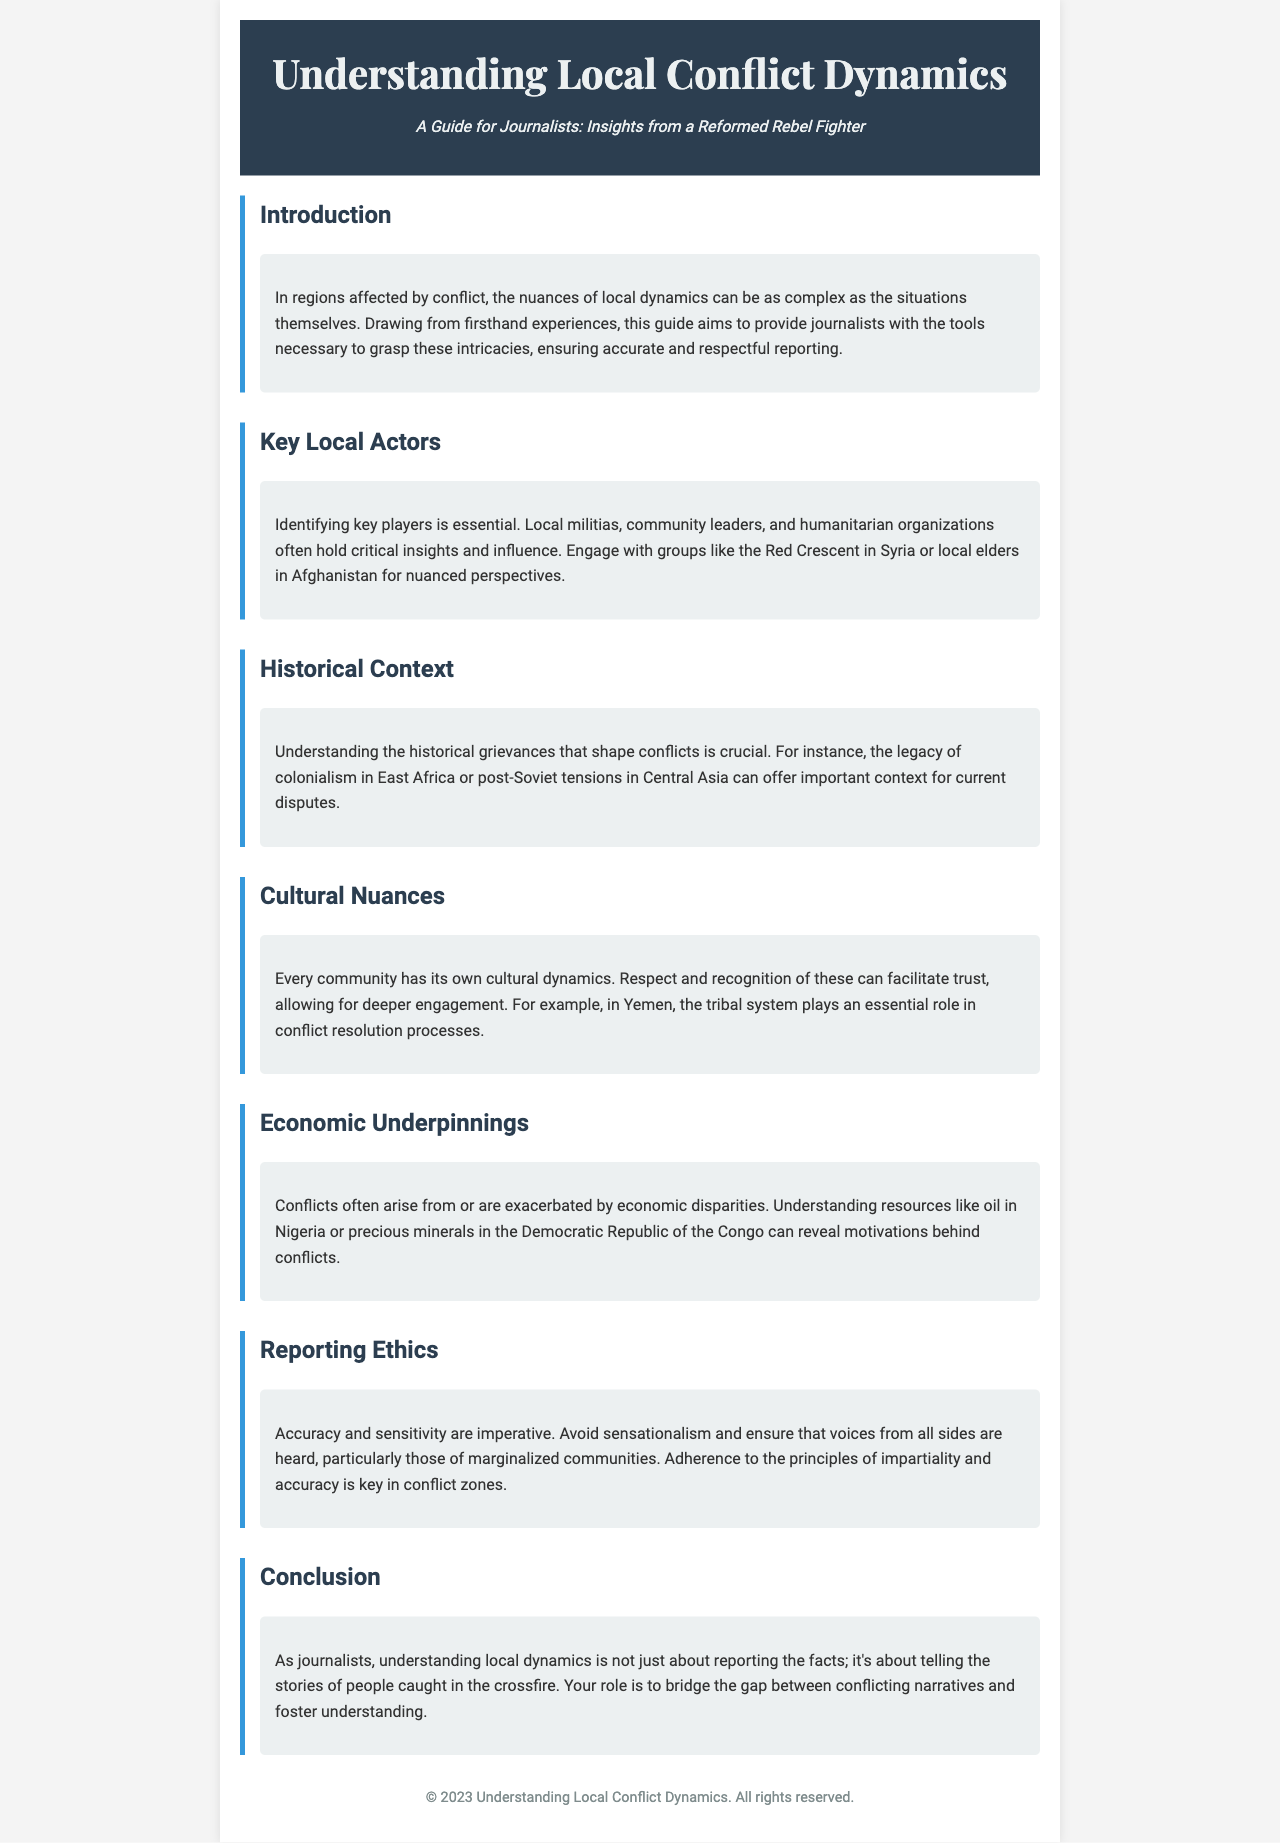What is the title of the brochure? The title of the brochure is prominently displayed in the header section.
Answer: Understanding Local Conflict Dynamics Who is the target audience for this guide? The guide is explicitly aimed at a specific audience mentioned in the subtitle.
Answer: Journalists What key local actors are mentioned in the document? The document lists various groups that play vital roles and influences in local contexts.
Answer: Local militias, community leaders, humanitarian organizations What historical context is highlighted in the brochure? The brochure discusses specific historical issues that inform current conflicts.
Answer: The legacy of colonialism in East Africa What cultural concept is emphasized in the guide? The document highlights the importance of understanding community-specific dynamics.
Answer: Tribal system in Yemen What is the main ethical principle suggested for journalists? The document stresses a crucial aspect of responsible reporting within conflict zones.
Answer: Accuracy and sensitivity What economic issue is discussed as a source of conflict? The brochure addresses underlying economic disparities that contribute to tensions.
Answer: Economic disparities What is the conclusion's main suggestion for journalists? The conclusion provides a significant insight on the journalists' role in conflict situations.
Answer: Bridge the gap between conflicting narratives 